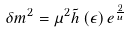Convert formula to latex. <formula><loc_0><loc_0><loc_500><loc_500>\delta m ^ { 2 } = \mu ^ { 2 } \tilde { h } \left ( \epsilon \right ) e ^ { \frac { 2 } { u } }</formula> 